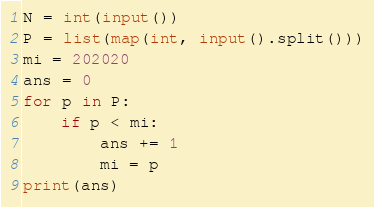Convert code to text. <code><loc_0><loc_0><loc_500><loc_500><_Python_>N = int(input())
P = list(map(int, input().split()))
mi = 202020
ans = 0
for p in P:
    if p < mi:
        ans += 1
        mi = p
print(ans)
</code> 